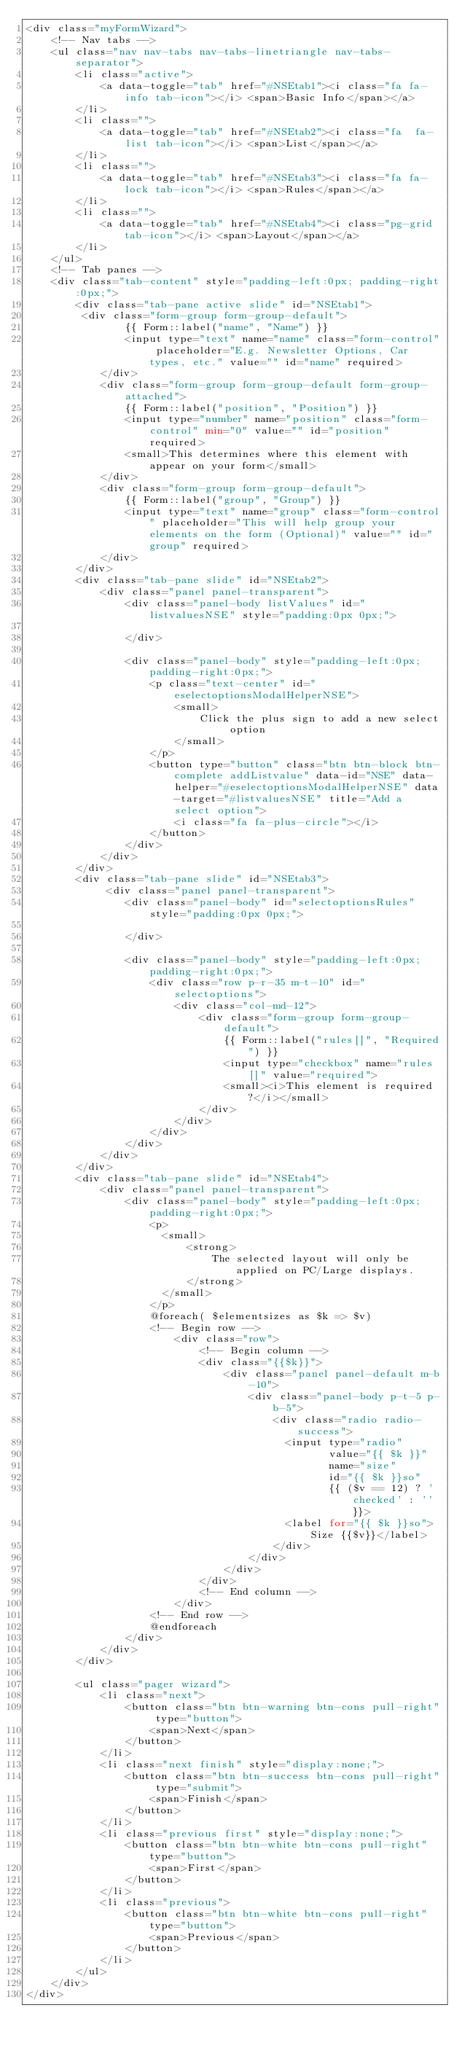<code> <loc_0><loc_0><loc_500><loc_500><_PHP_><div class="myFormWizard">
    <!-- Nav tabs -->
    <ul class="nav nav-tabs nav-tabs-linetriangle nav-tabs-separator">
        <li class="active">
            <a data-toggle="tab" href="#NSEtab1"><i class="fa fa-info tab-icon"></i> <span>Basic Info</span></a>
        </li>
        <li class="">
            <a data-toggle="tab" href="#NSEtab2"><i class="fa  fa-list tab-icon"></i> <span>List</span></a>
        </li>
        <li class="">
            <a data-toggle="tab" href="#NSEtab3"><i class="fa fa-lock tab-icon"></i> <span>Rules</span></a>
        </li>
        <li class="">
            <a data-toggle="tab" href="#NSEtab4"><i class="pg-grid tab-icon"></i> <span>Layout</span></a>
        </li>
    </ul>
    <!-- Tab panes -->
    <div class="tab-content" style="padding-left:0px; padding-right:0px;">
        <div class="tab-pane active slide" id="NSEtab1">
         <div class="form-group form-group-default">
                {{ Form::label("name", "Name") }}
                <input type="text" name="name" class="form-control" placeholder="E.g. Newsletter Options, Car types, etc." value="" id="name" required>
            </div>
            <div class="form-group form-group-default form-group-attached">
                {{ Form::label("position", "Position") }}
                <input type="number" name="position" class="form-control" min="0" value="" id="position" required>
                <small>This determines where this element with appear on your form</small>
            </div>
            <div class="form-group form-group-default">
                {{ Form::label("group", "Group") }}
                <input type="text" name="group" class="form-control" placeholder="This will help group your elements on the form (Optional)" value="" id="group" required>
            </div>
        </div>
        <div class="tab-pane slide" id="NSEtab2">
            <div class="panel panel-transparent">
                <div class="panel-body listValues" id="listvaluesNSE" style="padding:0px 0px;">
                  
                </div>

                <div class="panel-body" style="padding-left:0px; padding-right:0px;">
                    <p class="text-center" id="eselectoptionsModalHelperNSE">
                        <small>
                            Click the plus sign to add a new select option
                        </small>
                    </p>
                    <button type="button" class="btn btn-block btn-complete addListvalue" data-id="NSE" data-helper="#eselectoptionsModalHelperNSE" data-target="#listvaluesNSE" title="Add a select option">
                        <i class="fa fa-plus-circle"></i>
                    </button>
                </div>
            </div>
        </div>
        <div class="tab-pane slide" id="NSEtab3">
             <div class="panel panel-transparent">
                <div class="panel-body" id="selectoptionsRules" style="padding:0px 0px;">
                    
                </div>

                <div class="panel-body" style="padding-left:0px; padding-right:0px;">
                    <div class="row p-r-35 m-t-10" id="selectoptions">
                        <div class="col-md-12">
                            <div class="form-group form-group-default">
                                {{ Form::label("rules[]", "Required") }}
                                <input type="checkbox" name="rules[]" value="required">
                                <small><i>This element is required?</i></small>
                            </div>
                        </div>
                    </div>
                </div>
            </div>
        </div>
        <div class="tab-pane slide" id="NSEtab4">
            <div class="panel panel-transparent">
                <div class="panel-body" style="padding-left:0px; padding-right:0px;">
                    <p>
                      <small>
                          <strong>
                              The selected layout will only be applied on PC/Large displays.
                          </strong>
                      </small>  
                    </p>
                    @foreach( $elementsizes as $k => $v)
                    <!-- Begin row -->
                        <div class="row">
                            <!-- Begin column -->
                            <div class="{{$k}}">
                                <div class="panel panel-default m-b-10">
                                    <div class="panel-body p-t-5 p-b-5">
                                        <div class="radio radio-success">
                                          <input type="radio" 
                                                 value="{{ $k }}" 
                                                 name="size" 
                                                 id="{{ $k }}so"
                                                 {{ ($v == 12) ? 'checked' : '' }}>
                                          <label for="{{ $k }}so">Size {{$v}}</label>
                                        </div>
                                    </div>
                                </div>
                            </div>
                            <!-- End column -->
                        </div>
                    <!-- End row -->
                    @endforeach
                </div>
            </div>
        </div>

        <ul class="pager wizard">
            <li class="next">
                <button class="btn btn-warning btn-cons pull-right" type="button">
                    <span>Next</span>
                </button>
            </li>
            <li class="next finish" style="display:none;">
                <button class="btn btn-success btn-cons pull-right" type="submit">
                    <span>Finish</span>
                </button>
            </li>
            <li class="previous first" style="display:none;">
                <button class="btn btn-white btn-cons pull-right" type="button">
                    <span>First</span>
                </button>
            </li>
            <li class="previous">
                <button class="btn btn-white btn-cons pull-right" type="button">
                    <span>Previous</span>
                </button>
            </li>
        </ul>
    </div>
</div></code> 